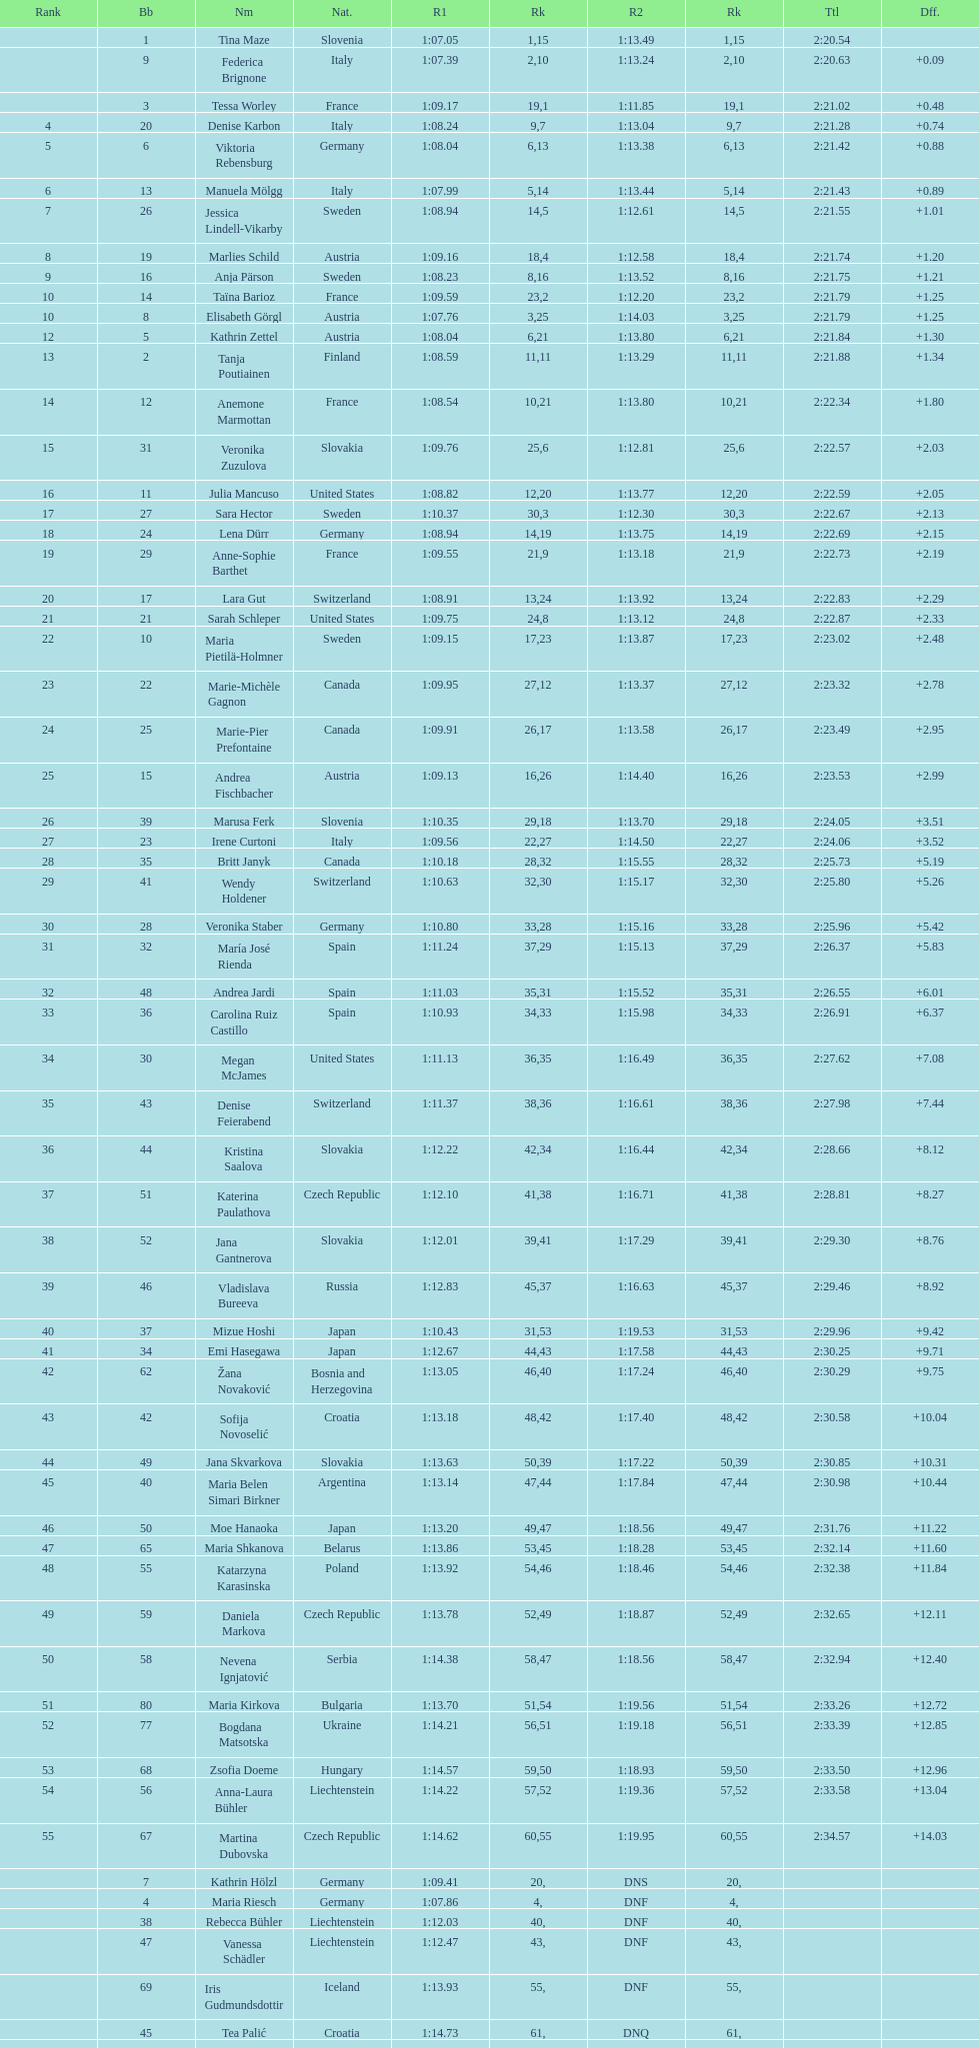How many italians finished in the top ten? 3. 